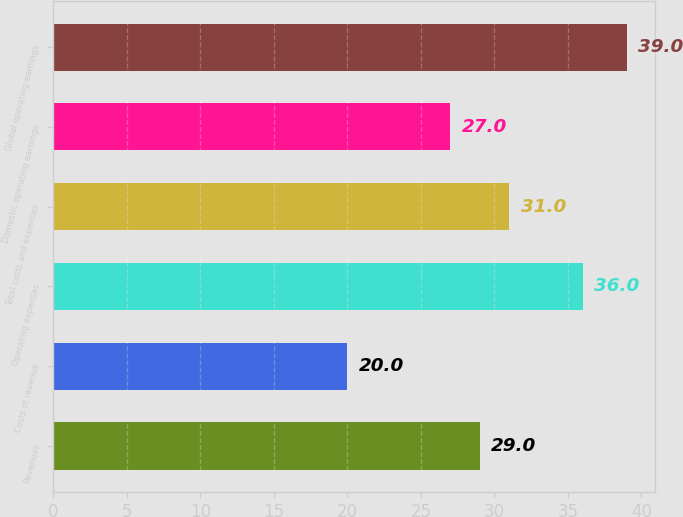Convert chart to OTSL. <chart><loc_0><loc_0><loc_500><loc_500><bar_chart><fcel>Revenues<fcel>Costs of revenue<fcel>Operating expenses<fcel>Total costs and expenses<fcel>Domestic operating earnings<fcel>Global operating earnings<nl><fcel>29<fcel>20<fcel>36<fcel>31<fcel>27<fcel>39<nl></chart> 